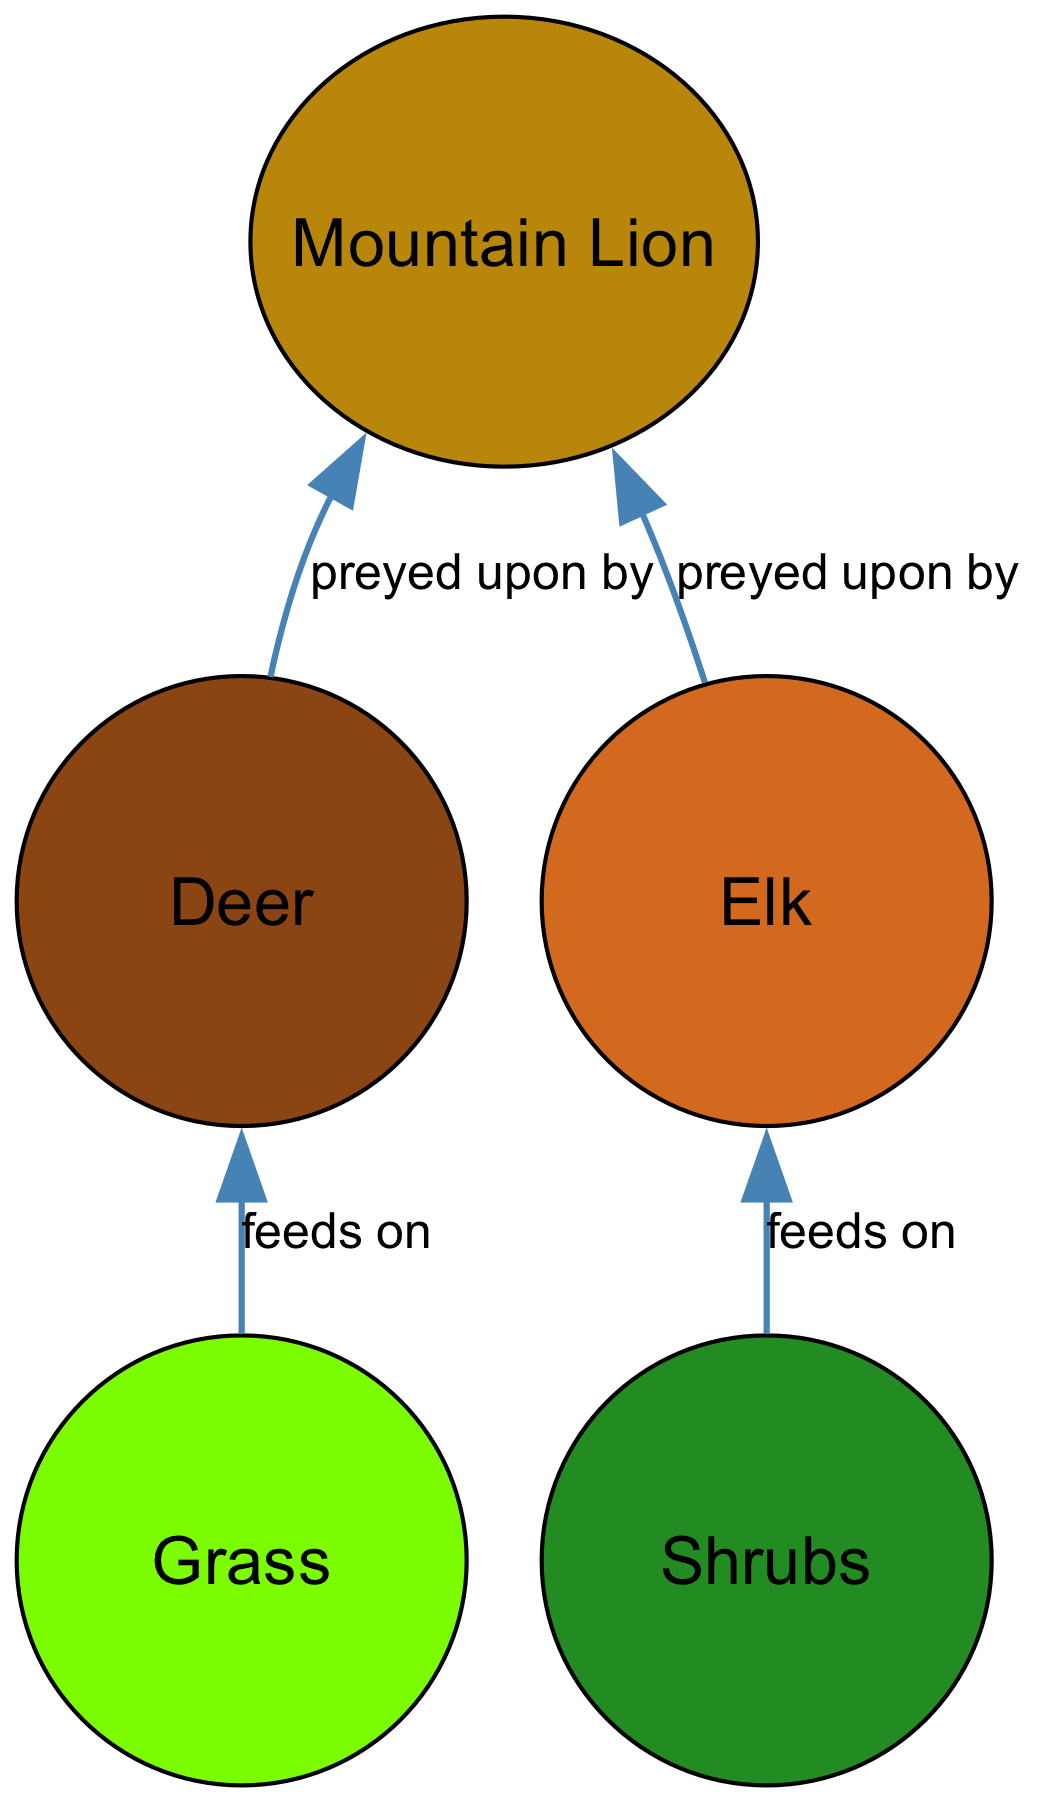What is the total number of nodes in the diagram? The diagram contains five distinct entities: Grass, Shrubs, Deer, Elk, and Mountain Lion. Counting these gives a total of five nodes.
Answer: 5 Which node is directly preyed upon by Mountain Lion? The diagram shows two direct relationships where Mountain Lion preys upon Deer and Elk. Both these nodes are connected to the Mountain Lion node with the edge labeled "preyed upon by."
Answer: Deer and Elk What do Grass feed on? The diagram indicates that Grass feeds on Deer, as illustrated by the edge labeled "feeds on" connecting Grass to Deer.
Answer: Deer Which node is at the top of the food chain in this diagram? In the context of this food chain, the Mountain Lion is depicted at the top, as it preys upon both Deer and Elk, representing the apex predator in this ecosystem.
Answer: Mountain Lion How many different types of plants are represented in the diagram? The diagram features two types of plants: Grass and Shrubs, each represented as separate nodes. The edges indicate their role as producers in the food chain.
Answer: 2 Which ungulate has a feeding relationship with Shrubs? The diagram shows a direct link between Shrubs and Elk, indicating that Elk feed on Shrubs. This relationship is labeled "feeds on."
Answer: Elk How many edges are connecting the nodes in this diagram? The diagram displays three edges that connect various nodes: one from Grass to Deer, one from Shrubs to Elk, and two from Deer and Elk to Mountain Lion, which sums up to four edges in total.
Answer: 4 What is the relationship between Deer and Mountain Lion? The connection labeled "preyed upon by" illustrates a predatory relationship where Mountain Lion hunts Deer, establishing Mountain Lion as a predator and Deer as prey.
Answer: Preyed upon by Which node represents a herbivorous animal in this food chain? The Deer and Elk nodes represent herbivorous animals in the food chain, as they feed on the plants (Grass and Shrubs).
Answer: Deer and Elk 